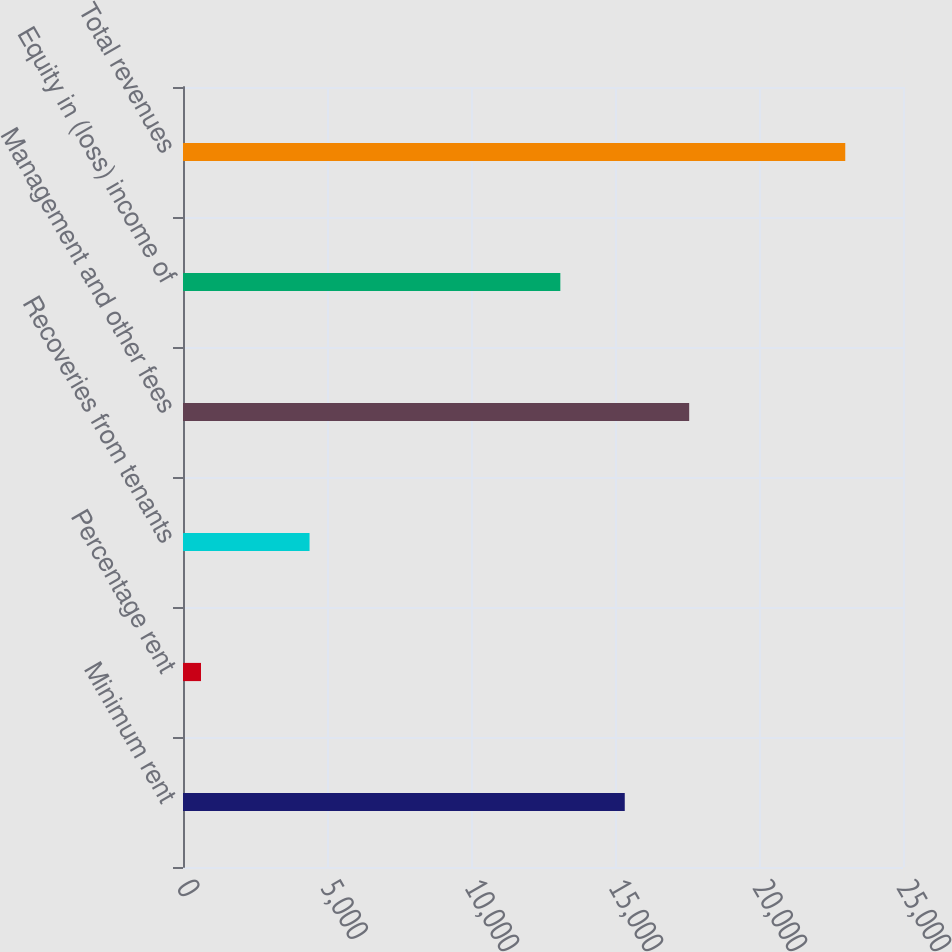<chart> <loc_0><loc_0><loc_500><loc_500><bar_chart><fcel>Minimum rent<fcel>Percentage rent<fcel>Recoveries from tenants<fcel>Management and other fees<fcel>Equity in (loss) income of<fcel>Total revenues<nl><fcel>15338.9<fcel>626<fcel>4394<fcel>17575.8<fcel>13102<fcel>22995<nl></chart> 